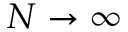<formula> <loc_0><loc_0><loc_500><loc_500>N \to \infty</formula> 